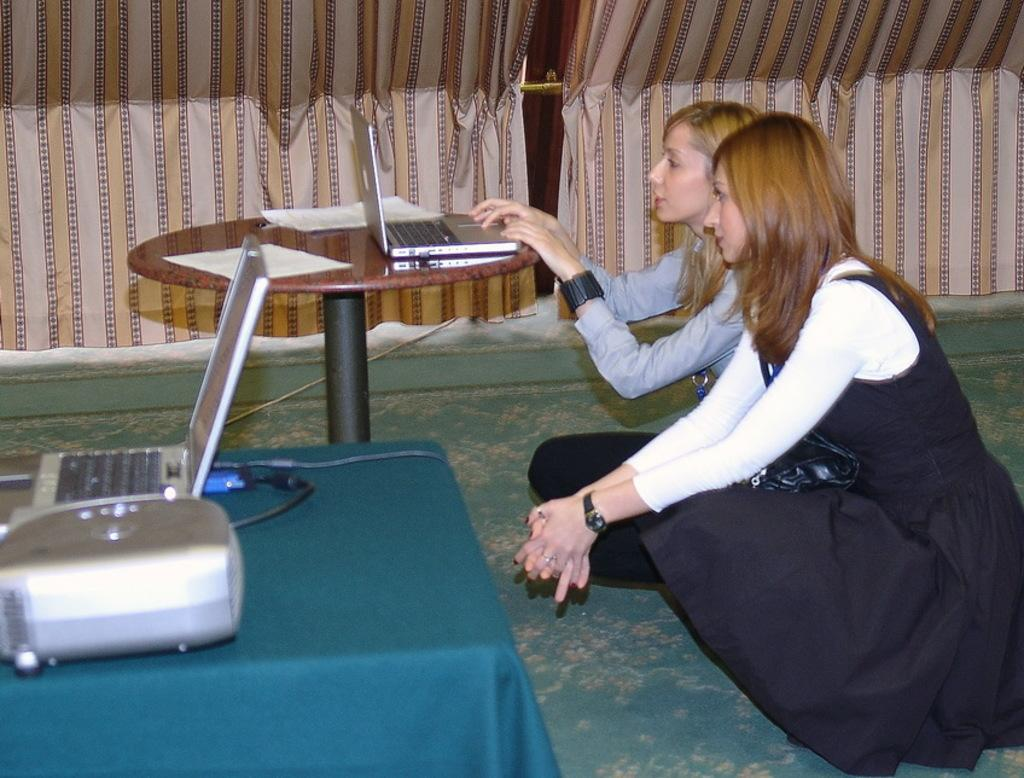How many people are in the image? There are two men in the image. What are the men looking at? The men are looking at a table. What is on the table in the image? There is a laptop and a projector on the table. What can be seen in the background of the image? There is a curtain in the background of the image. What word is written on the laptop screen in the image? There is no word visible on the laptop screen in the image. 